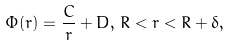Convert formula to latex. <formula><loc_0><loc_0><loc_500><loc_500>\Phi ( r ) = \frac { C } { r } + D , \, R < r < R + \delta ,</formula> 